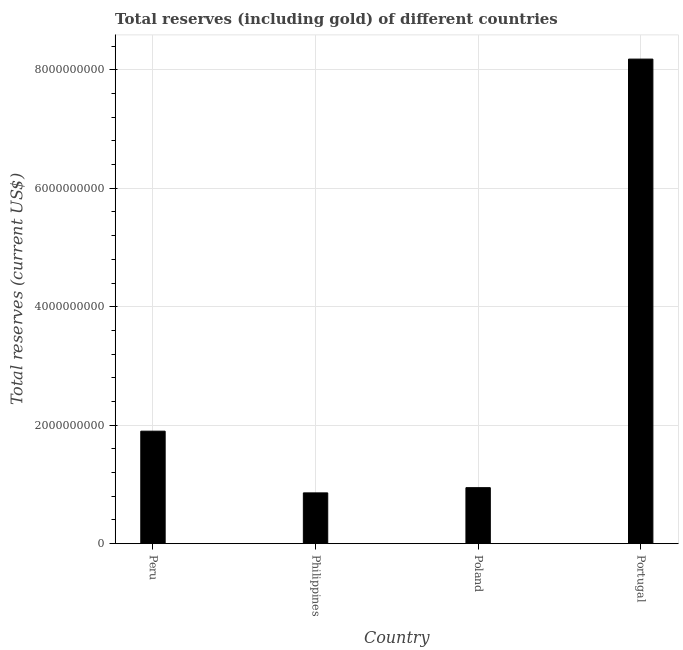Does the graph contain any zero values?
Your answer should be very brief. No. Does the graph contain grids?
Your answer should be compact. Yes. What is the title of the graph?
Your answer should be very brief. Total reserves (including gold) of different countries. What is the label or title of the X-axis?
Offer a very short reply. Country. What is the label or title of the Y-axis?
Offer a very short reply. Total reserves (current US$). What is the total reserves (including gold) in Peru?
Keep it short and to the point. 1.90e+09. Across all countries, what is the maximum total reserves (including gold)?
Give a very brief answer. 8.18e+09. Across all countries, what is the minimum total reserves (including gold)?
Provide a short and direct response. 8.57e+08. In which country was the total reserves (including gold) minimum?
Offer a very short reply. Philippines. What is the sum of the total reserves (including gold)?
Your response must be concise. 1.19e+1. What is the difference between the total reserves (including gold) in Philippines and Poland?
Ensure brevity in your answer.  -8.81e+07. What is the average total reserves (including gold) per country?
Your response must be concise. 2.97e+09. What is the median total reserves (including gold)?
Provide a succinct answer. 1.42e+09. What is the ratio of the total reserves (including gold) in Peru to that in Poland?
Provide a short and direct response. 2.01. What is the difference between the highest and the second highest total reserves (including gold)?
Your answer should be compact. 6.28e+09. What is the difference between the highest and the lowest total reserves (including gold)?
Provide a short and direct response. 7.32e+09. In how many countries, is the total reserves (including gold) greater than the average total reserves (including gold) taken over all countries?
Make the answer very short. 1. Are all the bars in the graph horizontal?
Provide a succinct answer. No. What is the Total reserves (current US$) in Peru?
Make the answer very short. 1.90e+09. What is the Total reserves (current US$) of Philippines?
Keep it short and to the point. 8.57e+08. What is the Total reserves (current US$) in Poland?
Ensure brevity in your answer.  9.45e+08. What is the Total reserves (current US$) in Portugal?
Your response must be concise. 8.18e+09. What is the difference between the Total reserves (current US$) in Peru and Philippines?
Your answer should be compact. 1.04e+09. What is the difference between the Total reserves (current US$) in Peru and Poland?
Your response must be concise. 9.54e+08. What is the difference between the Total reserves (current US$) in Peru and Portugal?
Provide a short and direct response. -6.28e+09. What is the difference between the Total reserves (current US$) in Philippines and Poland?
Keep it short and to the point. -8.81e+07. What is the difference between the Total reserves (current US$) in Philippines and Portugal?
Ensure brevity in your answer.  -7.32e+09. What is the difference between the Total reserves (current US$) in Poland and Portugal?
Give a very brief answer. -7.24e+09. What is the ratio of the Total reserves (current US$) in Peru to that in Philippines?
Your answer should be compact. 2.21. What is the ratio of the Total reserves (current US$) in Peru to that in Poland?
Keep it short and to the point. 2.01. What is the ratio of the Total reserves (current US$) in Peru to that in Portugal?
Your response must be concise. 0.23. What is the ratio of the Total reserves (current US$) in Philippines to that in Poland?
Keep it short and to the point. 0.91. What is the ratio of the Total reserves (current US$) in Philippines to that in Portugal?
Provide a short and direct response. 0.1. What is the ratio of the Total reserves (current US$) in Poland to that in Portugal?
Your answer should be compact. 0.12. 